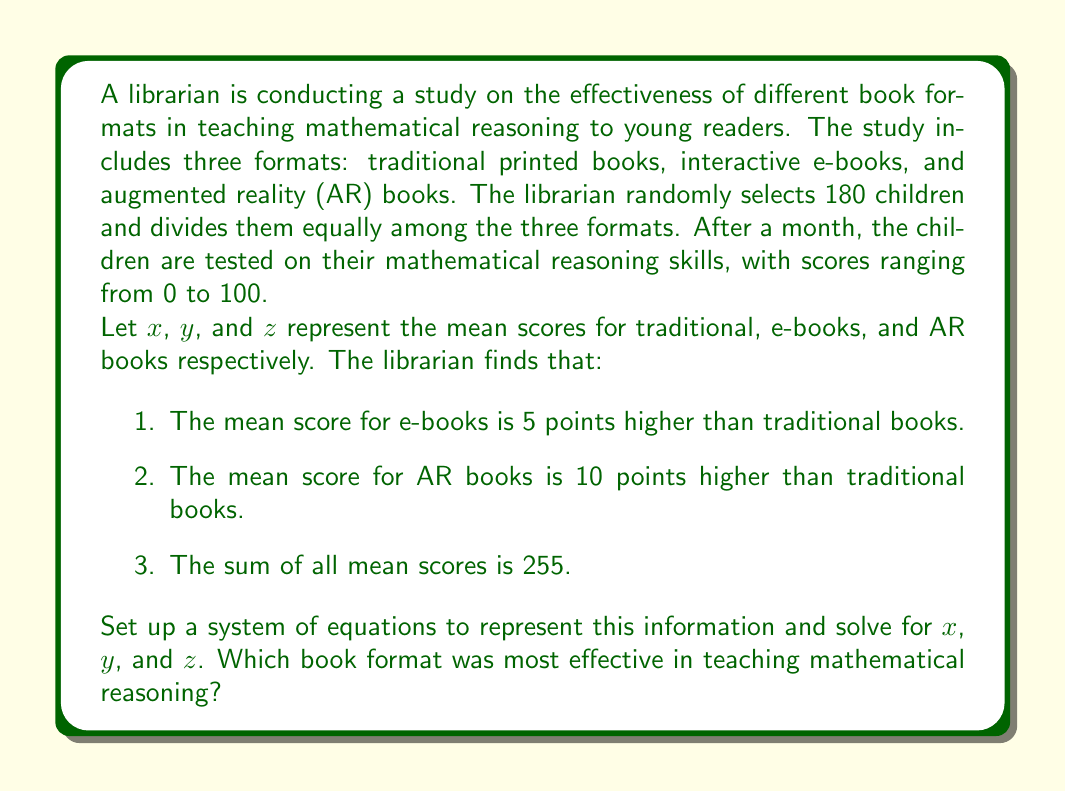Give your solution to this math problem. Let's approach this problem step-by-step:

1. We can set up three equations based on the given information:

   Equation 1: $y = x + 5$ (e-books score 5 points higher than traditional)
   Equation 2: $z = x + 10$ (AR books score 10 points higher than traditional)
   Equation 3: $x + y + z = 255$ (sum of all mean scores)

2. Substitute the expressions for $y$ and $z$ from equations 1 and 2 into equation 3:

   $x + (x + 5) + (x + 10) = 255$

3. Simplify the equation:

   $3x + 15 = 255$

4. Solve for $x$:

   $3x = 240$
   $x = 80$

5. Now that we know $x$, we can find $y$ and $z$:

   $y = x + 5 = 80 + 5 = 85$
   $z = x + 10 = 80 + 10 = 90$

6. Verify the solution:

   $x + y + z = 80 + 85 + 90 = 255$

Therefore, the mean scores are:
- Traditional books (x): 80
- E-books (y): 85
- AR books (z): 90

The AR books format was the most effective in teaching mathematical reasoning, with the highest mean score of 90.
Answer: Traditional books (x): 80
E-books (y): 85
AR books (z): 90

AR books were most effective with a mean score of 90. 